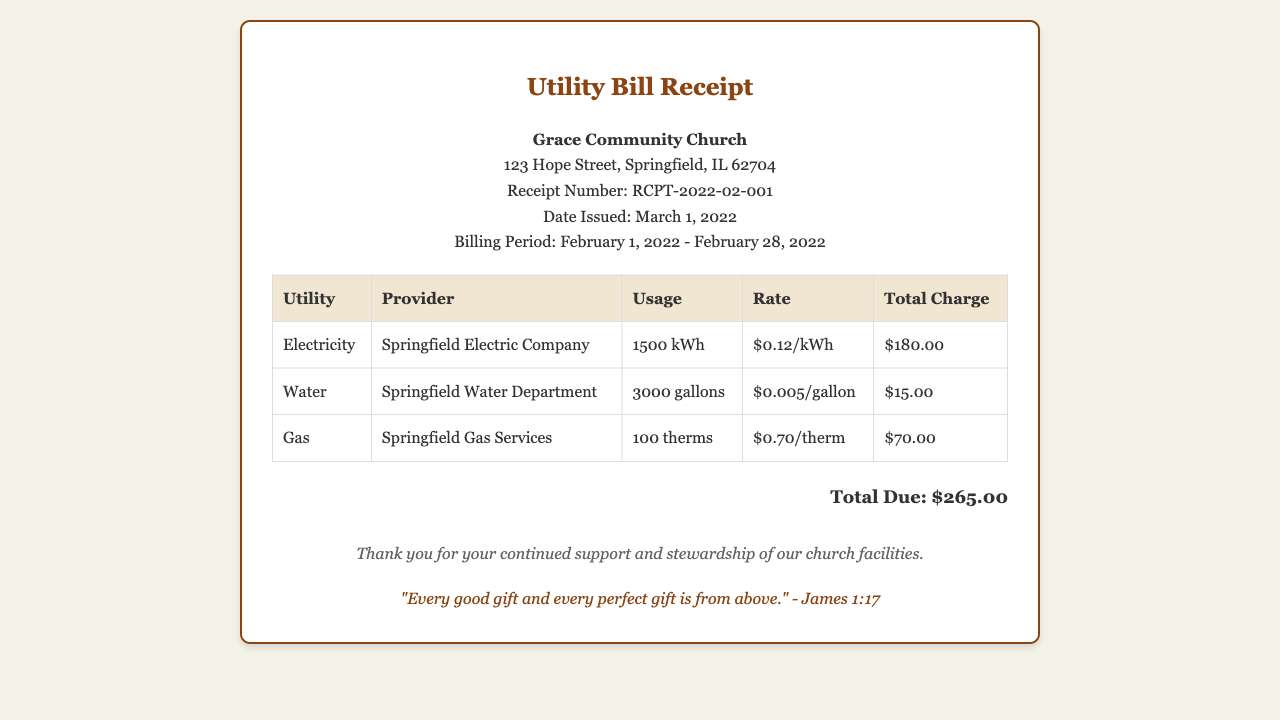What is the total due amount? The total due amount is listed at the bottom of the receipt and is the sum of all utility charges, which is $265.00.
Answer: $265.00 What is the billing period? The billing period specifies the dates for which the charges apply and is stated in the header of the receipt as February 1, 2022 - February 28, 2022.
Answer: February 1, 2022 - February 28, 2022 How much was charged for electricity? The charge for electricity is provided in the utility table under the "Total Charge" column for electricity, which is $180.00.
Answer: $180.00 What was the water usage? The water usage is recorded in the utility table under the "Usage" column for water, which is specified as 3000 gallons.
Answer: 3000 gallons Who provides the gas service? The provider of the gas service is listed in the utility table under the "Provider" column for gas, which is Springfield Gas Services.
Answer: Springfield Gas Services What is the rate per therm for gas? The rate for gas is found in the utility table under the "Rate" column for gas, which is $0.70/therm.
Answer: $0.70/therm What scripture is included at the bottom of the receipt? The scripture included is found in the last section of the receipt and states a specific biblical verse, which is "Every good gift and every perfect gift is from above."
Answer: "Every good gift and every perfect gift is from above." What is the usage of electricity? The usage for electricity is detailed in the utility table under the "Usage" column for electricity, which is 1500 kWh.
Answer: 1500 kWh What is the receipt number? The receipt number is stated in the header section and uniquely identifies this utility receipt, which is RCPT-2022-02-001.
Answer: RCPT-2022-02-001 